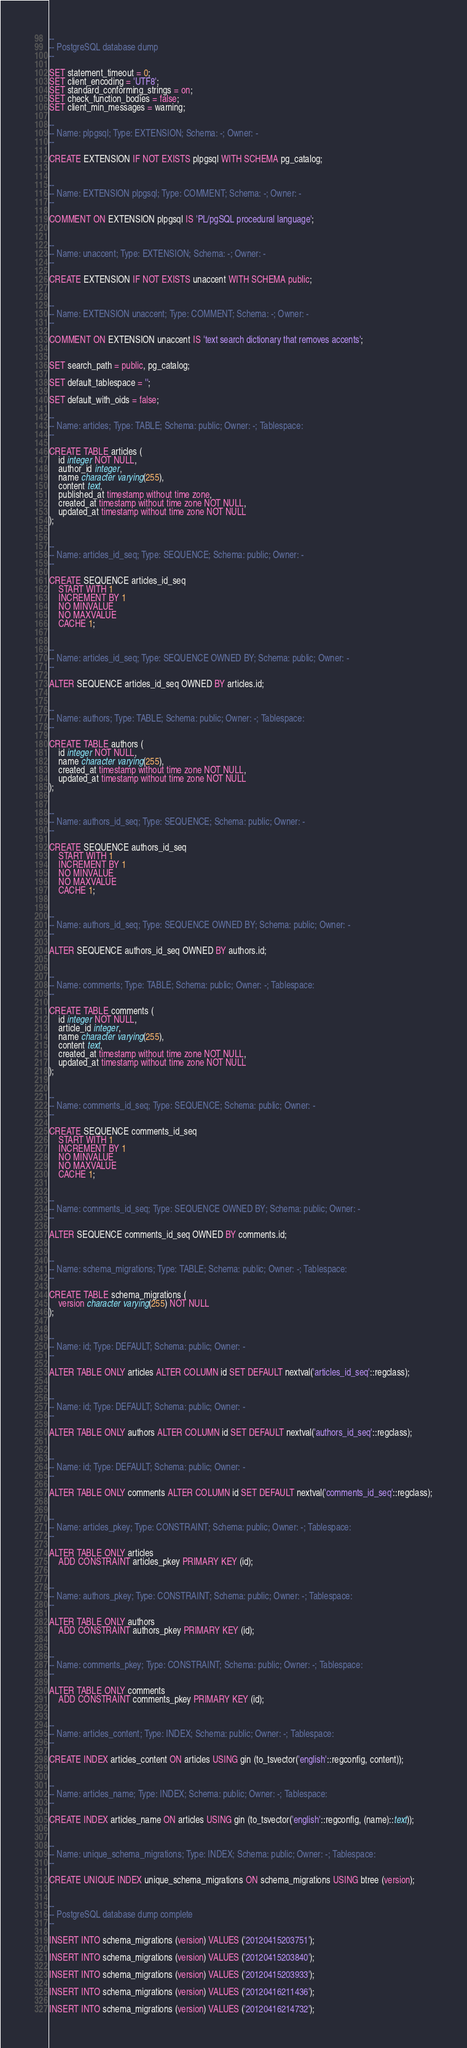Convert code to text. <code><loc_0><loc_0><loc_500><loc_500><_SQL_>--
-- PostgreSQL database dump
--

SET statement_timeout = 0;
SET client_encoding = 'UTF8';
SET standard_conforming_strings = on;
SET check_function_bodies = false;
SET client_min_messages = warning;

--
-- Name: plpgsql; Type: EXTENSION; Schema: -; Owner: -
--

CREATE EXTENSION IF NOT EXISTS plpgsql WITH SCHEMA pg_catalog;


--
-- Name: EXTENSION plpgsql; Type: COMMENT; Schema: -; Owner: -
--

COMMENT ON EXTENSION plpgsql IS 'PL/pgSQL procedural language';


--
-- Name: unaccent; Type: EXTENSION; Schema: -; Owner: -
--

CREATE EXTENSION IF NOT EXISTS unaccent WITH SCHEMA public;


--
-- Name: EXTENSION unaccent; Type: COMMENT; Schema: -; Owner: -
--

COMMENT ON EXTENSION unaccent IS 'text search dictionary that removes accents';


SET search_path = public, pg_catalog;

SET default_tablespace = '';

SET default_with_oids = false;

--
-- Name: articles; Type: TABLE; Schema: public; Owner: -; Tablespace: 
--

CREATE TABLE articles (
    id integer NOT NULL,
    author_id integer,
    name character varying(255),
    content text,
    published_at timestamp without time zone,
    created_at timestamp without time zone NOT NULL,
    updated_at timestamp without time zone NOT NULL
);


--
-- Name: articles_id_seq; Type: SEQUENCE; Schema: public; Owner: -
--

CREATE SEQUENCE articles_id_seq
    START WITH 1
    INCREMENT BY 1
    NO MINVALUE
    NO MAXVALUE
    CACHE 1;


--
-- Name: articles_id_seq; Type: SEQUENCE OWNED BY; Schema: public; Owner: -
--

ALTER SEQUENCE articles_id_seq OWNED BY articles.id;


--
-- Name: authors; Type: TABLE; Schema: public; Owner: -; Tablespace: 
--

CREATE TABLE authors (
    id integer NOT NULL,
    name character varying(255),
    created_at timestamp without time zone NOT NULL,
    updated_at timestamp without time zone NOT NULL
);


--
-- Name: authors_id_seq; Type: SEQUENCE; Schema: public; Owner: -
--

CREATE SEQUENCE authors_id_seq
    START WITH 1
    INCREMENT BY 1
    NO MINVALUE
    NO MAXVALUE
    CACHE 1;


--
-- Name: authors_id_seq; Type: SEQUENCE OWNED BY; Schema: public; Owner: -
--

ALTER SEQUENCE authors_id_seq OWNED BY authors.id;


--
-- Name: comments; Type: TABLE; Schema: public; Owner: -; Tablespace: 
--

CREATE TABLE comments (
    id integer NOT NULL,
    article_id integer,
    name character varying(255),
    content text,
    created_at timestamp without time zone NOT NULL,
    updated_at timestamp without time zone NOT NULL
);


--
-- Name: comments_id_seq; Type: SEQUENCE; Schema: public; Owner: -
--

CREATE SEQUENCE comments_id_seq
    START WITH 1
    INCREMENT BY 1
    NO MINVALUE
    NO MAXVALUE
    CACHE 1;


--
-- Name: comments_id_seq; Type: SEQUENCE OWNED BY; Schema: public; Owner: -
--

ALTER SEQUENCE comments_id_seq OWNED BY comments.id;


--
-- Name: schema_migrations; Type: TABLE; Schema: public; Owner: -; Tablespace: 
--

CREATE TABLE schema_migrations (
    version character varying(255) NOT NULL
);


--
-- Name: id; Type: DEFAULT; Schema: public; Owner: -
--

ALTER TABLE ONLY articles ALTER COLUMN id SET DEFAULT nextval('articles_id_seq'::regclass);


--
-- Name: id; Type: DEFAULT; Schema: public; Owner: -
--

ALTER TABLE ONLY authors ALTER COLUMN id SET DEFAULT nextval('authors_id_seq'::regclass);


--
-- Name: id; Type: DEFAULT; Schema: public; Owner: -
--

ALTER TABLE ONLY comments ALTER COLUMN id SET DEFAULT nextval('comments_id_seq'::regclass);


--
-- Name: articles_pkey; Type: CONSTRAINT; Schema: public; Owner: -; Tablespace: 
--

ALTER TABLE ONLY articles
    ADD CONSTRAINT articles_pkey PRIMARY KEY (id);


--
-- Name: authors_pkey; Type: CONSTRAINT; Schema: public; Owner: -; Tablespace: 
--

ALTER TABLE ONLY authors
    ADD CONSTRAINT authors_pkey PRIMARY KEY (id);


--
-- Name: comments_pkey; Type: CONSTRAINT; Schema: public; Owner: -; Tablespace: 
--

ALTER TABLE ONLY comments
    ADD CONSTRAINT comments_pkey PRIMARY KEY (id);


--
-- Name: articles_content; Type: INDEX; Schema: public; Owner: -; Tablespace: 
--

CREATE INDEX articles_content ON articles USING gin (to_tsvector('english'::regconfig, content));


--
-- Name: articles_name; Type: INDEX; Schema: public; Owner: -; Tablespace: 
--

CREATE INDEX articles_name ON articles USING gin (to_tsvector('english'::regconfig, (name)::text));


--
-- Name: unique_schema_migrations; Type: INDEX; Schema: public; Owner: -; Tablespace: 
--

CREATE UNIQUE INDEX unique_schema_migrations ON schema_migrations USING btree (version);


--
-- PostgreSQL database dump complete
--

INSERT INTO schema_migrations (version) VALUES ('20120415203751');

INSERT INTO schema_migrations (version) VALUES ('20120415203840');

INSERT INTO schema_migrations (version) VALUES ('20120415203933');

INSERT INTO schema_migrations (version) VALUES ('20120416211436');

INSERT INTO schema_migrations (version) VALUES ('20120416214732');</code> 